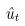<formula> <loc_0><loc_0><loc_500><loc_500>\hat { u } _ { t }</formula> 